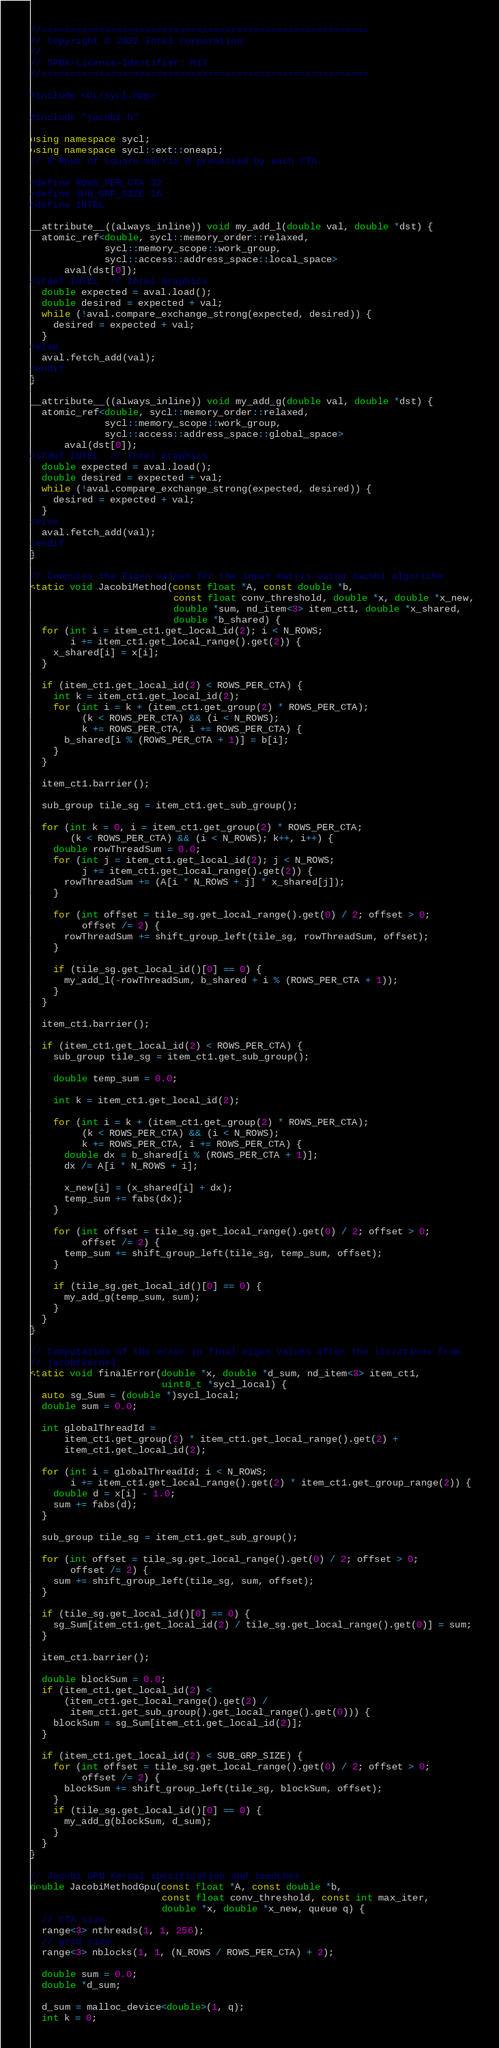Convert code to text. <code><loc_0><loc_0><loc_500><loc_500><_C++_>//=========================================================
// Copyright © 2022 Intel Corporation
//
// SPDX-License-Identifier: MIT
//=========================================================

#include <CL/sycl.hpp>

#include "jacobi.h"

using namespace sycl;
using namespace sycl::ext::oneapi;
// 8 Rows of square-matrix A processed by each CTA.

#define ROWS_PER_CTA 32
#define SUB_GRP_SIZE 16
#define INTEL

__attribute__((always_inline)) void my_add_l(double val, double *dst) {
  atomic_ref<double, sycl::memory_order::relaxed,
             sycl::memory_scope::work_group,
             sycl::access::address_space::local_space>
      aval(dst[0]);
#ifdef INTEL  // Intel Graphics
  double expected = aval.load();
  double desired = expected + val;
  while (!aval.compare_exchange_strong(expected, desired)) {
    desired = expected + val;
  }
#else
  aval.fetch_add(val);
#endif
}

__attribute__((always_inline)) void my_add_g(double val, double *dst) {
  atomic_ref<double, sycl::memory_order::relaxed,
             sycl::memory_scope::work_group,
             sycl::access::address_space::global_space>
      aval(dst[0]);
#ifdef INTEL  // Intel Graphics
  double expected = aval.load();
  double desired = expected + val;
  while (!aval.compare_exchange_strong(expected, desired)) {
    desired = expected + val;
  }
#else
  aval.fetch_add(val);
#endif
}

// Computes the Eigen values for the input matrix using Jacobi algorithm
static void JacobiMethod(const float *A, const double *b,
                         const float conv_threshold, double *x, double *x_new,
                         double *sum, nd_item<3> item_ct1, double *x_shared,
                         double *b_shared) {
  for (int i = item_ct1.get_local_id(2); i < N_ROWS;
       i += item_ct1.get_local_range().get(2)) {
    x_shared[i] = x[i];
  }

  if (item_ct1.get_local_id(2) < ROWS_PER_CTA) {
    int k = item_ct1.get_local_id(2);
    for (int i = k + (item_ct1.get_group(2) * ROWS_PER_CTA);
         (k < ROWS_PER_CTA) && (i < N_ROWS);
         k += ROWS_PER_CTA, i += ROWS_PER_CTA) {
      b_shared[i % (ROWS_PER_CTA + 1)] = b[i];
    }
  }

  item_ct1.barrier();

  sub_group tile_sg = item_ct1.get_sub_group();

  for (int k = 0, i = item_ct1.get_group(2) * ROWS_PER_CTA;
       (k < ROWS_PER_CTA) && (i < N_ROWS); k++, i++) {
    double rowThreadSum = 0.0;
    for (int j = item_ct1.get_local_id(2); j < N_ROWS;
         j += item_ct1.get_local_range().get(2)) {
      rowThreadSum += (A[i * N_ROWS + j] * x_shared[j]);
    }

    for (int offset = tile_sg.get_local_range().get(0) / 2; offset > 0;
         offset /= 2) {
      rowThreadSum += shift_group_left(tile_sg, rowThreadSum, offset);
    }

    if (tile_sg.get_local_id()[0] == 0) {
      my_add_l(-rowThreadSum, b_shared + i % (ROWS_PER_CTA + 1));
    }
  }

  item_ct1.barrier();

  if (item_ct1.get_local_id(2) < ROWS_PER_CTA) {
    sub_group tile_sg = item_ct1.get_sub_group();

    double temp_sum = 0.0;

    int k = item_ct1.get_local_id(2);

    for (int i = k + (item_ct1.get_group(2) * ROWS_PER_CTA);
         (k < ROWS_PER_CTA) && (i < N_ROWS);
         k += ROWS_PER_CTA, i += ROWS_PER_CTA) {
      double dx = b_shared[i % (ROWS_PER_CTA + 1)];
      dx /= A[i * N_ROWS + i];

      x_new[i] = (x_shared[i] + dx);
      temp_sum += fabs(dx);
    }

    for (int offset = tile_sg.get_local_range().get(0) / 2; offset > 0;
         offset /= 2) {
      temp_sum += shift_group_left(tile_sg, temp_sum, offset);
    }

    if (tile_sg.get_local_id()[0] == 0) {
      my_add_g(temp_sum, sum);
    }
  }
}

// Computation of the error in final eigen values after the iterations from
// jacobikernel
static void finalError(double *x, double *d_sum, nd_item<3> item_ct1,
                       uint8_t *sycl_local) {
  auto sg_Sum = (double *)sycl_local;
  double sum = 0.0;

  int globalThreadId =
      item_ct1.get_group(2) * item_ct1.get_local_range().get(2) +
      item_ct1.get_local_id(2);

  for (int i = globalThreadId; i < N_ROWS;
       i += item_ct1.get_local_range().get(2) * item_ct1.get_group_range(2)) {
    double d = x[i] - 1.0;
    sum += fabs(d);
  }

  sub_group tile_sg = item_ct1.get_sub_group();

  for (int offset = tile_sg.get_local_range().get(0) / 2; offset > 0;
       offset /= 2) {
    sum += shift_group_left(tile_sg, sum, offset);
  }

  if (tile_sg.get_local_id()[0] == 0) {
    sg_Sum[item_ct1.get_local_id(2) / tile_sg.get_local_range().get(0)] = sum;
  }

  item_ct1.barrier();

  double blockSum = 0.0;
  if (item_ct1.get_local_id(2) <
      (item_ct1.get_local_range().get(2) /
       item_ct1.get_sub_group().get_local_range().get(0))) {
    blockSum = sg_Sum[item_ct1.get_local_id(2)];
  }

  if (item_ct1.get_local_id(2) < SUB_GRP_SIZE) {
    for (int offset = tile_sg.get_local_range().get(0) / 2; offset > 0;
         offset /= 2) {
      blockSum += shift_group_left(tile_sg, blockSum, offset);
    }
    if (tile_sg.get_local_id()[0] == 0) {
      my_add_g(blockSum, d_sum);
    }
  }
}

// Jacobi GPU Kernal specification and launches
double JacobiMethodGpu(const float *A, const double *b,
                       const float conv_threshold, const int max_iter,
                       double *x, double *x_new, queue q) {
  // CTA size
  range<3> nthreads(1, 1, 256);
  // grid size
  range<3> nblocks(1, 1, (N_ROWS / ROWS_PER_CTA) + 2);

  double sum = 0.0;
  double *d_sum;

  d_sum = malloc_device<double>(1, q);
  int k = 0;
</code> 